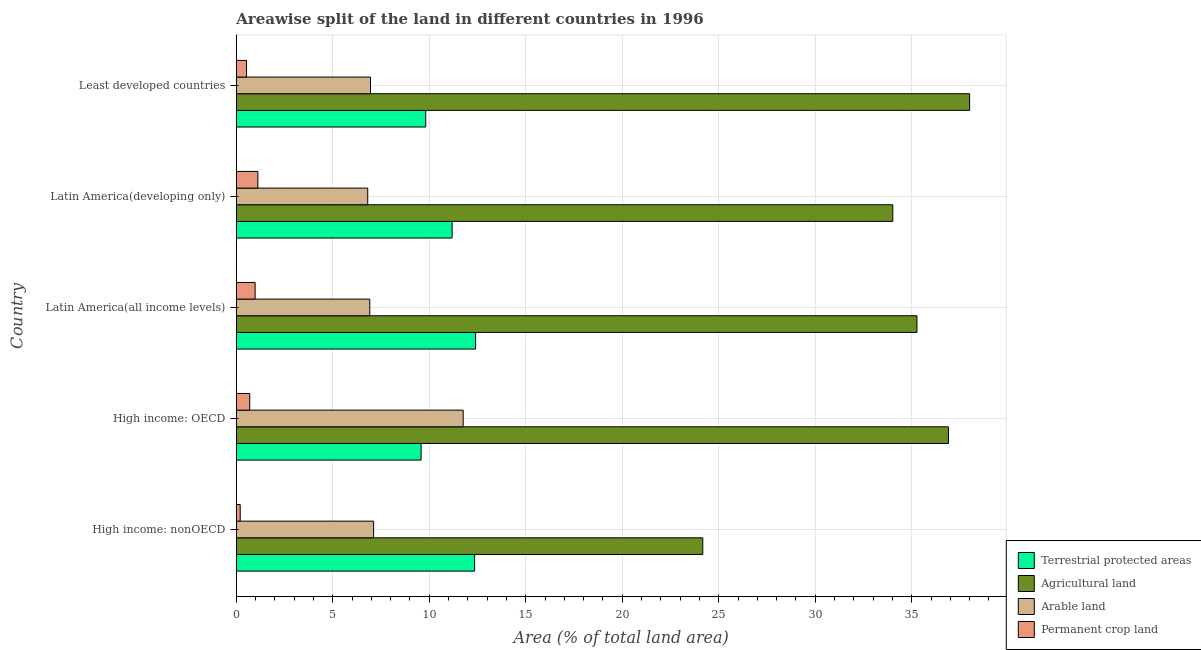How many different coloured bars are there?
Your answer should be very brief. 4. How many groups of bars are there?
Make the answer very short. 5. Are the number of bars per tick equal to the number of legend labels?
Make the answer very short. Yes. Are the number of bars on each tick of the Y-axis equal?
Make the answer very short. Yes. How many bars are there on the 3rd tick from the bottom?
Ensure brevity in your answer.  4. What is the label of the 1st group of bars from the top?
Give a very brief answer. Least developed countries. What is the percentage of land under terrestrial protection in Least developed countries?
Offer a very short reply. 9.82. Across all countries, what is the maximum percentage of area under arable land?
Your response must be concise. 11.76. Across all countries, what is the minimum percentage of area under agricultural land?
Offer a terse response. 24.17. In which country was the percentage of area under agricultural land maximum?
Provide a succinct answer. Least developed countries. In which country was the percentage of land under terrestrial protection minimum?
Your answer should be compact. High income: OECD. What is the total percentage of area under arable land in the graph?
Offer a terse response. 39.56. What is the difference between the percentage of land under terrestrial protection in Latin America(all income levels) and that in Least developed countries?
Provide a short and direct response. 2.58. What is the difference between the percentage of area under arable land in High income: OECD and the percentage of area under permanent crop land in Latin America(developing only)?
Your answer should be very brief. 10.64. What is the average percentage of area under agricultural land per country?
Your answer should be compact. 33.67. What is the difference between the percentage of area under agricultural land and percentage of area under arable land in Latin America(all income levels)?
Your answer should be very brief. 28.35. What is the ratio of the percentage of land under terrestrial protection in High income: nonOECD to that in Least developed countries?
Your answer should be compact. 1.26. What is the difference between the highest and the second highest percentage of area under agricultural land?
Give a very brief answer. 1.1. What is the difference between the highest and the lowest percentage of area under agricultural land?
Offer a terse response. 13.83. Is it the case that in every country, the sum of the percentage of area under permanent crop land and percentage of area under arable land is greater than the sum of percentage of land under terrestrial protection and percentage of area under agricultural land?
Provide a short and direct response. No. What does the 4th bar from the top in High income: OECD represents?
Offer a terse response. Terrestrial protected areas. What does the 2nd bar from the bottom in Latin America(all income levels) represents?
Offer a terse response. Agricultural land. Are all the bars in the graph horizontal?
Your response must be concise. Yes. What is the difference between two consecutive major ticks on the X-axis?
Your answer should be compact. 5. Are the values on the major ticks of X-axis written in scientific E-notation?
Your response must be concise. No. Does the graph contain any zero values?
Your answer should be very brief. No. Does the graph contain grids?
Provide a succinct answer. Yes. Where does the legend appear in the graph?
Your answer should be very brief. Bottom right. How are the legend labels stacked?
Your response must be concise. Vertical. What is the title of the graph?
Give a very brief answer. Areawise split of the land in different countries in 1996. What is the label or title of the X-axis?
Offer a very short reply. Area (% of total land area). What is the label or title of the Y-axis?
Provide a succinct answer. Country. What is the Area (% of total land area) in Terrestrial protected areas in High income: nonOECD?
Give a very brief answer. 12.35. What is the Area (% of total land area) in Agricultural land in High income: nonOECD?
Your response must be concise. 24.17. What is the Area (% of total land area) in Arable land in High income: nonOECD?
Provide a succinct answer. 7.12. What is the Area (% of total land area) of Permanent crop land in High income: nonOECD?
Your response must be concise. 0.21. What is the Area (% of total land area) of Terrestrial protected areas in High income: OECD?
Ensure brevity in your answer.  9.58. What is the Area (% of total land area) of Agricultural land in High income: OECD?
Ensure brevity in your answer.  36.9. What is the Area (% of total land area) of Arable land in High income: OECD?
Keep it short and to the point. 11.76. What is the Area (% of total land area) in Permanent crop land in High income: OECD?
Offer a very short reply. 0.7. What is the Area (% of total land area) of Terrestrial protected areas in Latin America(all income levels)?
Keep it short and to the point. 12.4. What is the Area (% of total land area) in Agricultural land in Latin America(all income levels)?
Give a very brief answer. 35.27. What is the Area (% of total land area) of Arable land in Latin America(all income levels)?
Your answer should be very brief. 6.92. What is the Area (% of total land area) of Permanent crop land in Latin America(all income levels)?
Your answer should be very brief. 0.98. What is the Area (% of total land area) in Terrestrial protected areas in Latin America(developing only)?
Your response must be concise. 11.19. What is the Area (% of total land area) in Agricultural land in Latin America(developing only)?
Ensure brevity in your answer.  34.02. What is the Area (% of total land area) of Arable land in Latin America(developing only)?
Ensure brevity in your answer.  6.81. What is the Area (% of total land area) of Permanent crop land in Latin America(developing only)?
Your response must be concise. 1.12. What is the Area (% of total land area) in Terrestrial protected areas in Least developed countries?
Offer a terse response. 9.82. What is the Area (% of total land area) in Agricultural land in Least developed countries?
Give a very brief answer. 38. What is the Area (% of total land area) in Arable land in Least developed countries?
Offer a terse response. 6.96. What is the Area (% of total land area) in Permanent crop land in Least developed countries?
Provide a short and direct response. 0.53. Across all countries, what is the maximum Area (% of total land area) of Terrestrial protected areas?
Your answer should be compact. 12.4. Across all countries, what is the maximum Area (% of total land area) in Agricultural land?
Give a very brief answer. 38. Across all countries, what is the maximum Area (% of total land area) in Arable land?
Give a very brief answer. 11.76. Across all countries, what is the maximum Area (% of total land area) of Permanent crop land?
Keep it short and to the point. 1.12. Across all countries, what is the minimum Area (% of total land area) in Terrestrial protected areas?
Ensure brevity in your answer.  9.58. Across all countries, what is the minimum Area (% of total land area) of Agricultural land?
Provide a succinct answer. 24.17. Across all countries, what is the minimum Area (% of total land area) in Arable land?
Ensure brevity in your answer.  6.81. Across all countries, what is the minimum Area (% of total land area) of Permanent crop land?
Your answer should be very brief. 0.21. What is the total Area (% of total land area) in Terrestrial protected areas in the graph?
Ensure brevity in your answer.  55.34. What is the total Area (% of total land area) of Agricultural land in the graph?
Keep it short and to the point. 168.37. What is the total Area (% of total land area) of Arable land in the graph?
Offer a very short reply. 39.56. What is the total Area (% of total land area) of Permanent crop land in the graph?
Make the answer very short. 3.53. What is the difference between the Area (% of total land area) of Terrestrial protected areas in High income: nonOECD and that in High income: OECD?
Ensure brevity in your answer.  2.77. What is the difference between the Area (% of total land area) of Agricultural land in High income: nonOECD and that in High income: OECD?
Make the answer very short. -12.73. What is the difference between the Area (% of total land area) of Arable land in High income: nonOECD and that in High income: OECD?
Provide a succinct answer. -4.64. What is the difference between the Area (% of total land area) of Permanent crop land in High income: nonOECD and that in High income: OECD?
Your answer should be compact. -0.49. What is the difference between the Area (% of total land area) of Terrestrial protected areas in High income: nonOECD and that in Latin America(all income levels)?
Offer a terse response. -0.05. What is the difference between the Area (% of total land area) in Agricultural land in High income: nonOECD and that in Latin America(all income levels)?
Your answer should be very brief. -11.1. What is the difference between the Area (% of total land area) in Arable land in High income: nonOECD and that in Latin America(all income levels)?
Your answer should be very brief. 0.2. What is the difference between the Area (% of total land area) of Permanent crop land in High income: nonOECD and that in Latin America(all income levels)?
Give a very brief answer. -0.77. What is the difference between the Area (% of total land area) in Terrestrial protected areas in High income: nonOECD and that in Latin America(developing only)?
Your response must be concise. 1.17. What is the difference between the Area (% of total land area) in Agricultural land in High income: nonOECD and that in Latin America(developing only)?
Keep it short and to the point. -9.85. What is the difference between the Area (% of total land area) in Arable land in High income: nonOECD and that in Latin America(developing only)?
Make the answer very short. 0.31. What is the difference between the Area (% of total land area) in Permanent crop land in High income: nonOECD and that in Latin America(developing only)?
Offer a very short reply. -0.91. What is the difference between the Area (% of total land area) of Terrestrial protected areas in High income: nonOECD and that in Least developed countries?
Offer a terse response. 2.53. What is the difference between the Area (% of total land area) in Agricultural land in High income: nonOECD and that in Least developed countries?
Provide a short and direct response. -13.83. What is the difference between the Area (% of total land area) in Arable land in High income: nonOECD and that in Least developed countries?
Give a very brief answer. 0.16. What is the difference between the Area (% of total land area) of Permanent crop land in High income: nonOECD and that in Least developed countries?
Your response must be concise. -0.33. What is the difference between the Area (% of total land area) of Terrestrial protected areas in High income: OECD and that in Latin America(all income levels)?
Make the answer very short. -2.82. What is the difference between the Area (% of total land area) in Agricultural land in High income: OECD and that in Latin America(all income levels)?
Give a very brief answer. 1.63. What is the difference between the Area (% of total land area) in Arable land in High income: OECD and that in Latin America(all income levels)?
Offer a very short reply. 4.84. What is the difference between the Area (% of total land area) in Permanent crop land in High income: OECD and that in Latin America(all income levels)?
Keep it short and to the point. -0.28. What is the difference between the Area (% of total land area) of Terrestrial protected areas in High income: OECD and that in Latin America(developing only)?
Your answer should be very brief. -1.61. What is the difference between the Area (% of total land area) in Agricultural land in High income: OECD and that in Latin America(developing only)?
Your answer should be very brief. 2.88. What is the difference between the Area (% of total land area) in Arable land in High income: OECD and that in Latin America(developing only)?
Keep it short and to the point. 4.95. What is the difference between the Area (% of total land area) in Permanent crop land in High income: OECD and that in Latin America(developing only)?
Offer a terse response. -0.42. What is the difference between the Area (% of total land area) of Terrestrial protected areas in High income: OECD and that in Least developed countries?
Provide a short and direct response. -0.24. What is the difference between the Area (% of total land area) in Agricultural land in High income: OECD and that in Least developed countries?
Provide a short and direct response. -1.1. What is the difference between the Area (% of total land area) of Arable land in High income: OECD and that in Least developed countries?
Keep it short and to the point. 4.8. What is the difference between the Area (% of total land area) in Permanent crop land in High income: OECD and that in Least developed countries?
Ensure brevity in your answer.  0.17. What is the difference between the Area (% of total land area) in Terrestrial protected areas in Latin America(all income levels) and that in Latin America(developing only)?
Provide a succinct answer. 1.22. What is the difference between the Area (% of total land area) in Agricultural land in Latin America(all income levels) and that in Latin America(developing only)?
Offer a terse response. 1.25. What is the difference between the Area (% of total land area) in Arable land in Latin America(all income levels) and that in Latin America(developing only)?
Offer a very short reply. 0.11. What is the difference between the Area (% of total land area) in Permanent crop land in Latin America(all income levels) and that in Latin America(developing only)?
Give a very brief answer. -0.14. What is the difference between the Area (% of total land area) in Terrestrial protected areas in Latin America(all income levels) and that in Least developed countries?
Provide a succinct answer. 2.58. What is the difference between the Area (% of total land area) in Agricultural land in Latin America(all income levels) and that in Least developed countries?
Keep it short and to the point. -2.73. What is the difference between the Area (% of total land area) in Arable land in Latin America(all income levels) and that in Least developed countries?
Make the answer very short. -0.04. What is the difference between the Area (% of total land area) of Permanent crop land in Latin America(all income levels) and that in Least developed countries?
Give a very brief answer. 0.45. What is the difference between the Area (% of total land area) in Terrestrial protected areas in Latin America(developing only) and that in Least developed countries?
Make the answer very short. 1.37. What is the difference between the Area (% of total land area) in Agricultural land in Latin America(developing only) and that in Least developed countries?
Make the answer very short. -3.98. What is the difference between the Area (% of total land area) in Arable land in Latin America(developing only) and that in Least developed countries?
Offer a very short reply. -0.14. What is the difference between the Area (% of total land area) in Permanent crop land in Latin America(developing only) and that in Least developed countries?
Give a very brief answer. 0.59. What is the difference between the Area (% of total land area) of Terrestrial protected areas in High income: nonOECD and the Area (% of total land area) of Agricultural land in High income: OECD?
Keep it short and to the point. -24.55. What is the difference between the Area (% of total land area) of Terrestrial protected areas in High income: nonOECD and the Area (% of total land area) of Arable land in High income: OECD?
Your response must be concise. 0.59. What is the difference between the Area (% of total land area) of Terrestrial protected areas in High income: nonOECD and the Area (% of total land area) of Permanent crop land in High income: OECD?
Ensure brevity in your answer.  11.65. What is the difference between the Area (% of total land area) of Agricultural land in High income: nonOECD and the Area (% of total land area) of Arable land in High income: OECD?
Ensure brevity in your answer.  12.42. What is the difference between the Area (% of total land area) of Agricultural land in High income: nonOECD and the Area (% of total land area) of Permanent crop land in High income: OECD?
Your answer should be compact. 23.48. What is the difference between the Area (% of total land area) of Arable land in High income: nonOECD and the Area (% of total land area) of Permanent crop land in High income: OECD?
Make the answer very short. 6.42. What is the difference between the Area (% of total land area) of Terrestrial protected areas in High income: nonOECD and the Area (% of total land area) of Agricultural land in Latin America(all income levels)?
Give a very brief answer. -22.92. What is the difference between the Area (% of total land area) of Terrestrial protected areas in High income: nonOECD and the Area (% of total land area) of Arable land in Latin America(all income levels)?
Your response must be concise. 5.43. What is the difference between the Area (% of total land area) of Terrestrial protected areas in High income: nonOECD and the Area (% of total land area) of Permanent crop land in Latin America(all income levels)?
Give a very brief answer. 11.37. What is the difference between the Area (% of total land area) of Agricultural land in High income: nonOECD and the Area (% of total land area) of Arable land in Latin America(all income levels)?
Give a very brief answer. 17.26. What is the difference between the Area (% of total land area) in Agricultural land in High income: nonOECD and the Area (% of total land area) in Permanent crop land in Latin America(all income levels)?
Your answer should be compact. 23.2. What is the difference between the Area (% of total land area) in Arable land in High income: nonOECD and the Area (% of total land area) in Permanent crop land in Latin America(all income levels)?
Give a very brief answer. 6.14. What is the difference between the Area (% of total land area) in Terrestrial protected areas in High income: nonOECD and the Area (% of total land area) in Agricultural land in Latin America(developing only)?
Your response must be concise. -21.67. What is the difference between the Area (% of total land area) in Terrestrial protected areas in High income: nonOECD and the Area (% of total land area) in Arable land in Latin America(developing only)?
Your answer should be compact. 5.54. What is the difference between the Area (% of total land area) of Terrestrial protected areas in High income: nonOECD and the Area (% of total land area) of Permanent crop land in Latin America(developing only)?
Offer a very short reply. 11.23. What is the difference between the Area (% of total land area) in Agricultural land in High income: nonOECD and the Area (% of total land area) in Arable land in Latin America(developing only)?
Give a very brief answer. 17.36. What is the difference between the Area (% of total land area) of Agricultural land in High income: nonOECD and the Area (% of total land area) of Permanent crop land in Latin America(developing only)?
Keep it short and to the point. 23.05. What is the difference between the Area (% of total land area) in Arable land in High income: nonOECD and the Area (% of total land area) in Permanent crop land in Latin America(developing only)?
Ensure brevity in your answer.  6. What is the difference between the Area (% of total land area) of Terrestrial protected areas in High income: nonOECD and the Area (% of total land area) of Agricultural land in Least developed countries?
Keep it short and to the point. -25.65. What is the difference between the Area (% of total land area) of Terrestrial protected areas in High income: nonOECD and the Area (% of total land area) of Arable land in Least developed countries?
Keep it short and to the point. 5.4. What is the difference between the Area (% of total land area) of Terrestrial protected areas in High income: nonOECD and the Area (% of total land area) of Permanent crop land in Least developed countries?
Provide a short and direct response. 11.82. What is the difference between the Area (% of total land area) in Agricultural land in High income: nonOECD and the Area (% of total land area) in Arable land in Least developed countries?
Offer a terse response. 17.22. What is the difference between the Area (% of total land area) of Agricultural land in High income: nonOECD and the Area (% of total land area) of Permanent crop land in Least developed countries?
Provide a short and direct response. 23.64. What is the difference between the Area (% of total land area) of Arable land in High income: nonOECD and the Area (% of total land area) of Permanent crop land in Least developed countries?
Give a very brief answer. 6.59. What is the difference between the Area (% of total land area) in Terrestrial protected areas in High income: OECD and the Area (% of total land area) in Agricultural land in Latin America(all income levels)?
Keep it short and to the point. -25.69. What is the difference between the Area (% of total land area) in Terrestrial protected areas in High income: OECD and the Area (% of total land area) in Arable land in Latin America(all income levels)?
Make the answer very short. 2.66. What is the difference between the Area (% of total land area) in Terrestrial protected areas in High income: OECD and the Area (% of total land area) in Permanent crop land in Latin America(all income levels)?
Your response must be concise. 8.6. What is the difference between the Area (% of total land area) in Agricultural land in High income: OECD and the Area (% of total land area) in Arable land in Latin America(all income levels)?
Your answer should be compact. 29.99. What is the difference between the Area (% of total land area) of Agricultural land in High income: OECD and the Area (% of total land area) of Permanent crop land in Latin America(all income levels)?
Your answer should be compact. 35.93. What is the difference between the Area (% of total land area) in Arable land in High income: OECD and the Area (% of total land area) in Permanent crop land in Latin America(all income levels)?
Give a very brief answer. 10.78. What is the difference between the Area (% of total land area) of Terrestrial protected areas in High income: OECD and the Area (% of total land area) of Agricultural land in Latin America(developing only)?
Your answer should be compact. -24.44. What is the difference between the Area (% of total land area) of Terrestrial protected areas in High income: OECD and the Area (% of total land area) of Arable land in Latin America(developing only)?
Your response must be concise. 2.77. What is the difference between the Area (% of total land area) in Terrestrial protected areas in High income: OECD and the Area (% of total land area) in Permanent crop land in Latin America(developing only)?
Provide a succinct answer. 8.46. What is the difference between the Area (% of total land area) in Agricultural land in High income: OECD and the Area (% of total land area) in Arable land in Latin America(developing only)?
Your answer should be compact. 30.09. What is the difference between the Area (% of total land area) in Agricultural land in High income: OECD and the Area (% of total land area) in Permanent crop land in Latin America(developing only)?
Your response must be concise. 35.79. What is the difference between the Area (% of total land area) of Arable land in High income: OECD and the Area (% of total land area) of Permanent crop land in Latin America(developing only)?
Make the answer very short. 10.64. What is the difference between the Area (% of total land area) of Terrestrial protected areas in High income: OECD and the Area (% of total land area) of Agricultural land in Least developed countries?
Your answer should be very brief. -28.42. What is the difference between the Area (% of total land area) in Terrestrial protected areas in High income: OECD and the Area (% of total land area) in Arable land in Least developed countries?
Offer a very short reply. 2.62. What is the difference between the Area (% of total land area) in Terrestrial protected areas in High income: OECD and the Area (% of total land area) in Permanent crop land in Least developed countries?
Make the answer very short. 9.05. What is the difference between the Area (% of total land area) in Agricultural land in High income: OECD and the Area (% of total land area) in Arable land in Least developed countries?
Provide a short and direct response. 29.95. What is the difference between the Area (% of total land area) of Agricultural land in High income: OECD and the Area (% of total land area) of Permanent crop land in Least developed countries?
Provide a succinct answer. 36.37. What is the difference between the Area (% of total land area) of Arable land in High income: OECD and the Area (% of total land area) of Permanent crop land in Least developed countries?
Your response must be concise. 11.23. What is the difference between the Area (% of total land area) of Terrestrial protected areas in Latin America(all income levels) and the Area (% of total land area) of Agricultural land in Latin America(developing only)?
Make the answer very short. -21.62. What is the difference between the Area (% of total land area) of Terrestrial protected areas in Latin America(all income levels) and the Area (% of total land area) of Arable land in Latin America(developing only)?
Your response must be concise. 5.59. What is the difference between the Area (% of total land area) in Terrestrial protected areas in Latin America(all income levels) and the Area (% of total land area) in Permanent crop land in Latin America(developing only)?
Provide a succinct answer. 11.28. What is the difference between the Area (% of total land area) in Agricultural land in Latin America(all income levels) and the Area (% of total land area) in Arable land in Latin America(developing only)?
Your answer should be very brief. 28.46. What is the difference between the Area (% of total land area) in Agricultural land in Latin America(all income levels) and the Area (% of total land area) in Permanent crop land in Latin America(developing only)?
Your response must be concise. 34.15. What is the difference between the Area (% of total land area) in Arable land in Latin America(all income levels) and the Area (% of total land area) in Permanent crop land in Latin America(developing only)?
Give a very brief answer. 5.8. What is the difference between the Area (% of total land area) of Terrestrial protected areas in Latin America(all income levels) and the Area (% of total land area) of Agricultural land in Least developed countries?
Keep it short and to the point. -25.6. What is the difference between the Area (% of total land area) in Terrestrial protected areas in Latin America(all income levels) and the Area (% of total land area) in Arable land in Least developed countries?
Ensure brevity in your answer.  5.45. What is the difference between the Area (% of total land area) in Terrestrial protected areas in Latin America(all income levels) and the Area (% of total land area) in Permanent crop land in Least developed countries?
Keep it short and to the point. 11.87. What is the difference between the Area (% of total land area) of Agricultural land in Latin America(all income levels) and the Area (% of total land area) of Arable land in Least developed countries?
Give a very brief answer. 28.32. What is the difference between the Area (% of total land area) of Agricultural land in Latin America(all income levels) and the Area (% of total land area) of Permanent crop land in Least developed countries?
Keep it short and to the point. 34.74. What is the difference between the Area (% of total land area) of Arable land in Latin America(all income levels) and the Area (% of total land area) of Permanent crop land in Least developed countries?
Give a very brief answer. 6.39. What is the difference between the Area (% of total land area) in Terrestrial protected areas in Latin America(developing only) and the Area (% of total land area) in Agricultural land in Least developed countries?
Offer a terse response. -26.81. What is the difference between the Area (% of total land area) in Terrestrial protected areas in Latin America(developing only) and the Area (% of total land area) in Arable land in Least developed countries?
Your answer should be compact. 4.23. What is the difference between the Area (% of total land area) in Terrestrial protected areas in Latin America(developing only) and the Area (% of total land area) in Permanent crop land in Least developed countries?
Offer a terse response. 10.65. What is the difference between the Area (% of total land area) of Agricultural land in Latin America(developing only) and the Area (% of total land area) of Arable land in Least developed countries?
Your response must be concise. 27.06. What is the difference between the Area (% of total land area) in Agricultural land in Latin America(developing only) and the Area (% of total land area) in Permanent crop land in Least developed countries?
Provide a short and direct response. 33.49. What is the difference between the Area (% of total land area) in Arable land in Latin America(developing only) and the Area (% of total land area) in Permanent crop land in Least developed countries?
Keep it short and to the point. 6.28. What is the average Area (% of total land area) of Terrestrial protected areas per country?
Make the answer very short. 11.07. What is the average Area (% of total land area) of Agricultural land per country?
Provide a succinct answer. 33.67. What is the average Area (% of total land area) in Arable land per country?
Make the answer very short. 7.91. What is the average Area (% of total land area) of Permanent crop land per country?
Offer a very short reply. 0.71. What is the difference between the Area (% of total land area) in Terrestrial protected areas and Area (% of total land area) in Agricultural land in High income: nonOECD?
Ensure brevity in your answer.  -11.82. What is the difference between the Area (% of total land area) in Terrestrial protected areas and Area (% of total land area) in Arable land in High income: nonOECD?
Keep it short and to the point. 5.23. What is the difference between the Area (% of total land area) in Terrestrial protected areas and Area (% of total land area) in Permanent crop land in High income: nonOECD?
Offer a very short reply. 12.15. What is the difference between the Area (% of total land area) in Agricultural land and Area (% of total land area) in Arable land in High income: nonOECD?
Your answer should be compact. 17.06. What is the difference between the Area (% of total land area) in Agricultural land and Area (% of total land area) in Permanent crop land in High income: nonOECD?
Keep it short and to the point. 23.97. What is the difference between the Area (% of total land area) of Arable land and Area (% of total land area) of Permanent crop land in High income: nonOECD?
Offer a very short reply. 6.91. What is the difference between the Area (% of total land area) in Terrestrial protected areas and Area (% of total land area) in Agricultural land in High income: OECD?
Ensure brevity in your answer.  -27.33. What is the difference between the Area (% of total land area) in Terrestrial protected areas and Area (% of total land area) in Arable land in High income: OECD?
Your answer should be very brief. -2.18. What is the difference between the Area (% of total land area) of Terrestrial protected areas and Area (% of total land area) of Permanent crop land in High income: OECD?
Provide a short and direct response. 8.88. What is the difference between the Area (% of total land area) of Agricultural land and Area (% of total land area) of Arable land in High income: OECD?
Keep it short and to the point. 25.15. What is the difference between the Area (% of total land area) of Agricultural land and Area (% of total land area) of Permanent crop land in High income: OECD?
Your response must be concise. 36.21. What is the difference between the Area (% of total land area) in Arable land and Area (% of total land area) in Permanent crop land in High income: OECD?
Offer a very short reply. 11.06. What is the difference between the Area (% of total land area) in Terrestrial protected areas and Area (% of total land area) in Agricultural land in Latin America(all income levels)?
Offer a terse response. -22.87. What is the difference between the Area (% of total land area) of Terrestrial protected areas and Area (% of total land area) of Arable land in Latin America(all income levels)?
Your answer should be very brief. 5.48. What is the difference between the Area (% of total land area) in Terrestrial protected areas and Area (% of total land area) in Permanent crop land in Latin America(all income levels)?
Ensure brevity in your answer.  11.42. What is the difference between the Area (% of total land area) in Agricultural land and Area (% of total land area) in Arable land in Latin America(all income levels)?
Your answer should be very brief. 28.35. What is the difference between the Area (% of total land area) in Agricultural land and Area (% of total land area) in Permanent crop land in Latin America(all income levels)?
Give a very brief answer. 34.29. What is the difference between the Area (% of total land area) of Arable land and Area (% of total land area) of Permanent crop land in Latin America(all income levels)?
Ensure brevity in your answer.  5.94. What is the difference between the Area (% of total land area) in Terrestrial protected areas and Area (% of total land area) in Agricultural land in Latin America(developing only)?
Offer a terse response. -22.83. What is the difference between the Area (% of total land area) in Terrestrial protected areas and Area (% of total land area) in Arable land in Latin America(developing only)?
Provide a short and direct response. 4.37. What is the difference between the Area (% of total land area) in Terrestrial protected areas and Area (% of total land area) in Permanent crop land in Latin America(developing only)?
Your answer should be compact. 10.07. What is the difference between the Area (% of total land area) in Agricultural land and Area (% of total land area) in Arable land in Latin America(developing only)?
Offer a very short reply. 27.21. What is the difference between the Area (% of total land area) in Agricultural land and Area (% of total land area) in Permanent crop land in Latin America(developing only)?
Provide a short and direct response. 32.9. What is the difference between the Area (% of total land area) in Arable land and Area (% of total land area) in Permanent crop land in Latin America(developing only)?
Keep it short and to the point. 5.69. What is the difference between the Area (% of total land area) of Terrestrial protected areas and Area (% of total land area) of Agricultural land in Least developed countries?
Provide a short and direct response. -28.18. What is the difference between the Area (% of total land area) of Terrestrial protected areas and Area (% of total land area) of Arable land in Least developed countries?
Ensure brevity in your answer.  2.86. What is the difference between the Area (% of total land area) of Terrestrial protected areas and Area (% of total land area) of Permanent crop land in Least developed countries?
Keep it short and to the point. 9.29. What is the difference between the Area (% of total land area) of Agricultural land and Area (% of total land area) of Arable land in Least developed countries?
Ensure brevity in your answer.  31.04. What is the difference between the Area (% of total land area) of Agricultural land and Area (% of total land area) of Permanent crop land in Least developed countries?
Your response must be concise. 37.47. What is the difference between the Area (% of total land area) of Arable land and Area (% of total land area) of Permanent crop land in Least developed countries?
Your answer should be very brief. 6.42. What is the ratio of the Area (% of total land area) of Terrestrial protected areas in High income: nonOECD to that in High income: OECD?
Provide a short and direct response. 1.29. What is the ratio of the Area (% of total land area) in Agricultural land in High income: nonOECD to that in High income: OECD?
Your response must be concise. 0.66. What is the ratio of the Area (% of total land area) of Arable land in High income: nonOECD to that in High income: OECD?
Offer a very short reply. 0.61. What is the ratio of the Area (% of total land area) in Permanent crop land in High income: nonOECD to that in High income: OECD?
Offer a terse response. 0.29. What is the ratio of the Area (% of total land area) of Terrestrial protected areas in High income: nonOECD to that in Latin America(all income levels)?
Ensure brevity in your answer.  1. What is the ratio of the Area (% of total land area) in Agricultural land in High income: nonOECD to that in Latin America(all income levels)?
Ensure brevity in your answer.  0.69. What is the ratio of the Area (% of total land area) in Arable land in High income: nonOECD to that in Latin America(all income levels)?
Provide a short and direct response. 1.03. What is the ratio of the Area (% of total land area) in Permanent crop land in High income: nonOECD to that in Latin America(all income levels)?
Your answer should be very brief. 0.21. What is the ratio of the Area (% of total land area) of Terrestrial protected areas in High income: nonOECD to that in Latin America(developing only)?
Give a very brief answer. 1.1. What is the ratio of the Area (% of total land area) in Agricultural land in High income: nonOECD to that in Latin America(developing only)?
Offer a terse response. 0.71. What is the ratio of the Area (% of total land area) of Arable land in High income: nonOECD to that in Latin America(developing only)?
Provide a short and direct response. 1.04. What is the ratio of the Area (% of total land area) of Permanent crop land in High income: nonOECD to that in Latin America(developing only)?
Offer a very short reply. 0.18. What is the ratio of the Area (% of total land area) in Terrestrial protected areas in High income: nonOECD to that in Least developed countries?
Offer a terse response. 1.26. What is the ratio of the Area (% of total land area) in Agricultural land in High income: nonOECD to that in Least developed countries?
Provide a succinct answer. 0.64. What is the ratio of the Area (% of total land area) in Arable land in High income: nonOECD to that in Least developed countries?
Your answer should be compact. 1.02. What is the ratio of the Area (% of total land area) in Permanent crop land in High income: nonOECD to that in Least developed countries?
Ensure brevity in your answer.  0.39. What is the ratio of the Area (% of total land area) of Terrestrial protected areas in High income: OECD to that in Latin America(all income levels)?
Provide a succinct answer. 0.77. What is the ratio of the Area (% of total land area) of Agricultural land in High income: OECD to that in Latin America(all income levels)?
Provide a succinct answer. 1.05. What is the ratio of the Area (% of total land area) of Arable land in High income: OECD to that in Latin America(all income levels)?
Your answer should be compact. 1.7. What is the ratio of the Area (% of total land area) of Permanent crop land in High income: OECD to that in Latin America(all income levels)?
Give a very brief answer. 0.71. What is the ratio of the Area (% of total land area) of Terrestrial protected areas in High income: OECD to that in Latin America(developing only)?
Provide a succinct answer. 0.86. What is the ratio of the Area (% of total land area) of Agricultural land in High income: OECD to that in Latin America(developing only)?
Make the answer very short. 1.08. What is the ratio of the Area (% of total land area) in Arable land in High income: OECD to that in Latin America(developing only)?
Your answer should be compact. 1.73. What is the ratio of the Area (% of total land area) in Permanent crop land in High income: OECD to that in Latin America(developing only)?
Make the answer very short. 0.62. What is the ratio of the Area (% of total land area) in Terrestrial protected areas in High income: OECD to that in Least developed countries?
Your answer should be compact. 0.98. What is the ratio of the Area (% of total land area) of Agricultural land in High income: OECD to that in Least developed countries?
Ensure brevity in your answer.  0.97. What is the ratio of the Area (% of total land area) of Arable land in High income: OECD to that in Least developed countries?
Make the answer very short. 1.69. What is the ratio of the Area (% of total land area) of Permanent crop land in High income: OECD to that in Least developed countries?
Ensure brevity in your answer.  1.31. What is the ratio of the Area (% of total land area) of Terrestrial protected areas in Latin America(all income levels) to that in Latin America(developing only)?
Ensure brevity in your answer.  1.11. What is the ratio of the Area (% of total land area) of Agricultural land in Latin America(all income levels) to that in Latin America(developing only)?
Offer a terse response. 1.04. What is the ratio of the Area (% of total land area) of Arable land in Latin America(all income levels) to that in Latin America(developing only)?
Keep it short and to the point. 1.02. What is the ratio of the Area (% of total land area) in Permanent crop land in Latin America(all income levels) to that in Latin America(developing only)?
Make the answer very short. 0.87. What is the ratio of the Area (% of total land area) in Terrestrial protected areas in Latin America(all income levels) to that in Least developed countries?
Offer a terse response. 1.26. What is the ratio of the Area (% of total land area) of Agricultural land in Latin America(all income levels) to that in Least developed countries?
Your response must be concise. 0.93. What is the ratio of the Area (% of total land area) in Permanent crop land in Latin America(all income levels) to that in Least developed countries?
Keep it short and to the point. 1.84. What is the ratio of the Area (% of total land area) of Terrestrial protected areas in Latin America(developing only) to that in Least developed countries?
Your response must be concise. 1.14. What is the ratio of the Area (% of total land area) in Agricultural land in Latin America(developing only) to that in Least developed countries?
Provide a short and direct response. 0.9. What is the ratio of the Area (% of total land area) in Arable land in Latin America(developing only) to that in Least developed countries?
Ensure brevity in your answer.  0.98. What is the ratio of the Area (% of total land area) of Permanent crop land in Latin America(developing only) to that in Least developed countries?
Ensure brevity in your answer.  2.1. What is the difference between the highest and the second highest Area (% of total land area) in Terrestrial protected areas?
Your answer should be compact. 0.05. What is the difference between the highest and the second highest Area (% of total land area) in Agricultural land?
Your answer should be compact. 1.1. What is the difference between the highest and the second highest Area (% of total land area) in Arable land?
Give a very brief answer. 4.64. What is the difference between the highest and the second highest Area (% of total land area) in Permanent crop land?
Your response must be concise. 0.14. What is the difference between the highest and the lowest Area (% of total land area) in Terrestrial protected areas?
Provide a succinct answer. 2.82. What is the difference between the highest and the lowest Area (% of total land area) in Agricultural land?
Make the answer very short. 13.83. What is the difference between the highest and the lowest Area (% of total land area) in Arable land?
Provide a succinct answer. 4.95. What is the difference between the highest and the lowest Area (% of total land area) of Permanent crop land?
Provide a short and direct response. 0.91. 